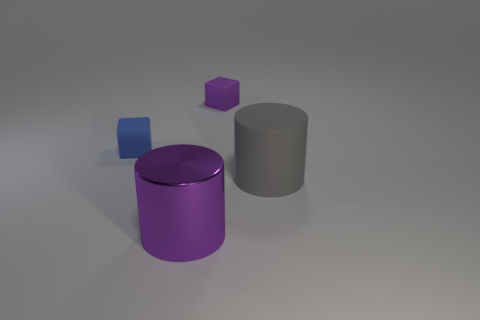What is the material of the cube that is behind the blue block?
Keep it short and to the point. Rubber. What size is the blue rubber thing?
Your answer should be compact. Small. What number of purple things are tiny things or metal cylinders?
Offer a terse response. 2. There is a blue block behind the purple object in front of the small blue cube; what size is it?
Offer a terse response. Small. Do the metal object and the small thing that is to the right of the blue object have the same color?
Keep it short and to the point. Yes. What number of other things are made of the same material as the blue block?
Offer a very short reply. 2. The big thing that is the same material as the purple block is what shape?
Your answer should be compact. Cylinder. Are there any other things of the same color as the metallic thing?
Give a very brief answer. Yes. Is the number of big gray rubber objects that are in front of the blue rubber thing greater than the number of big green matte spheres?
Ensure brevity in your answer.  Yes. There is a large rubber thing; is it the same shape as the small thing to the left of the large shiny cylinder?
Your response must be concise. No. 